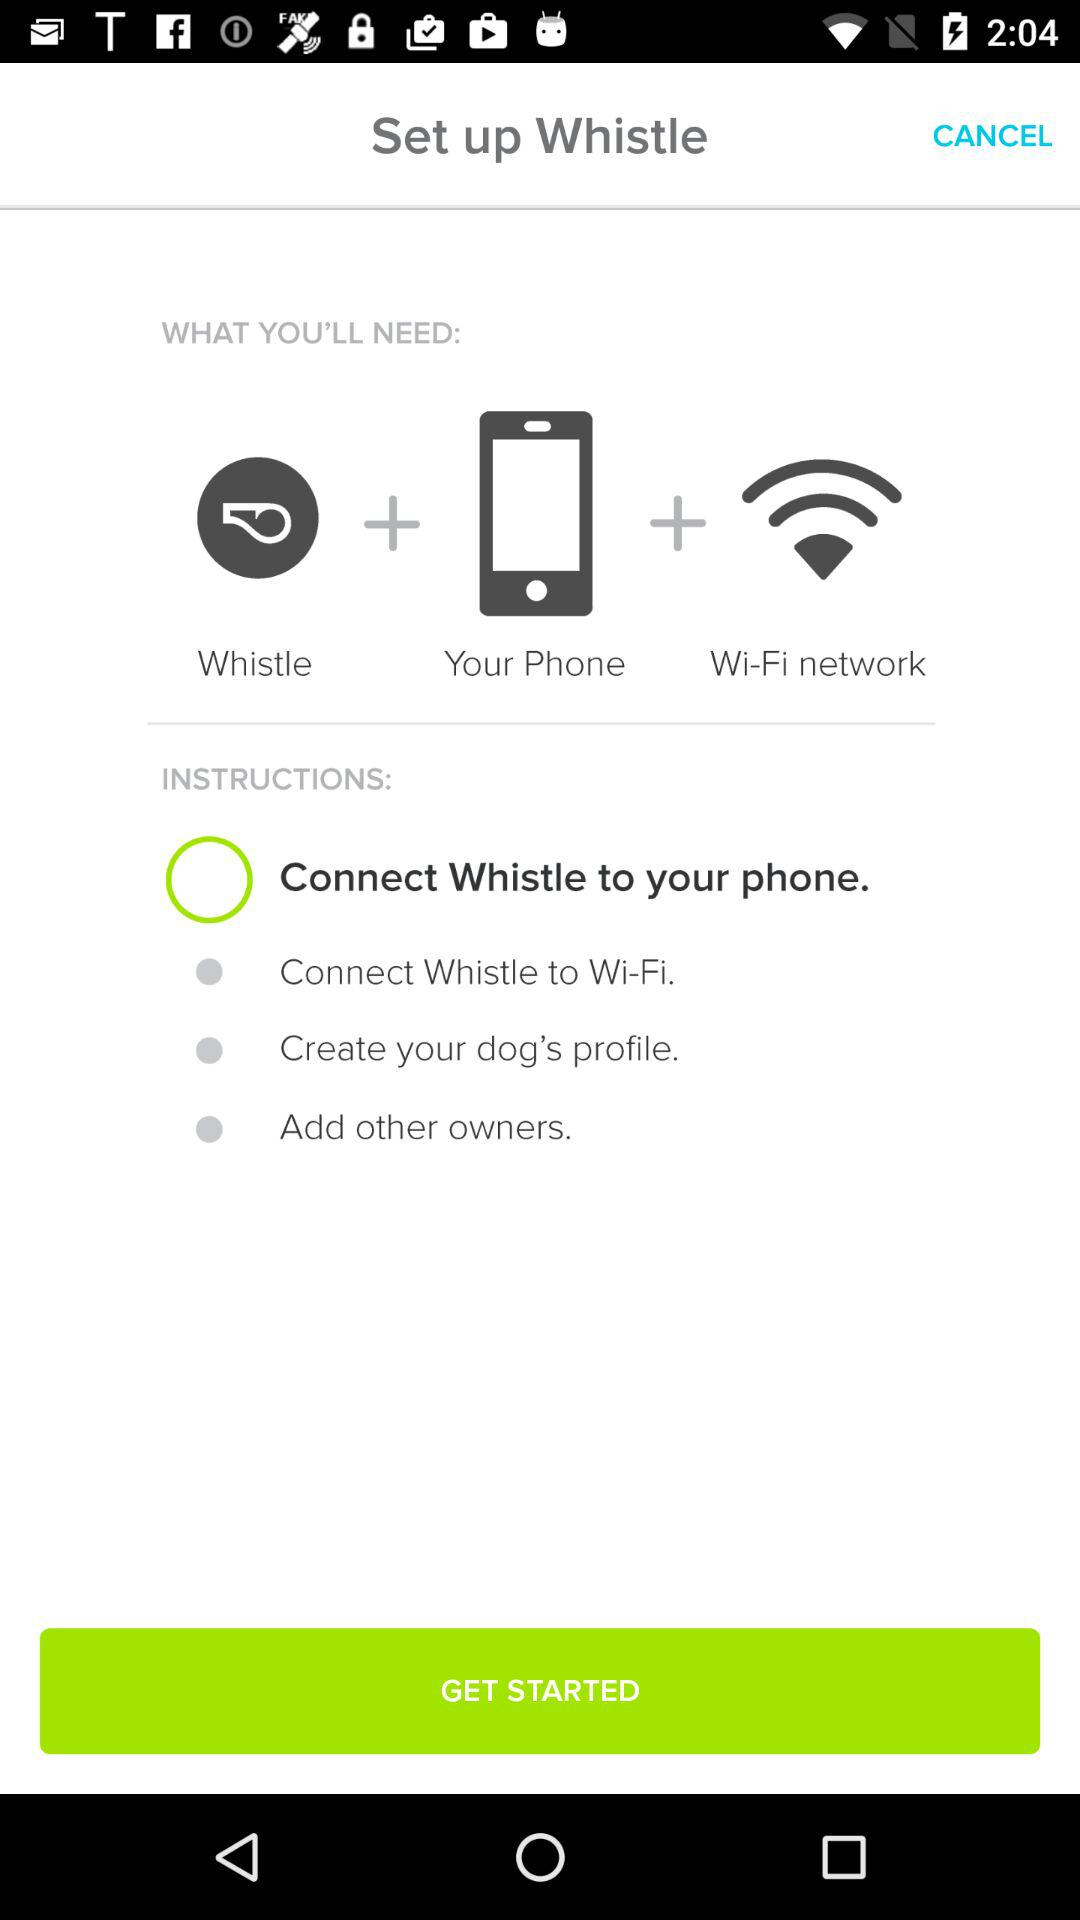What devices are needed to set up the whistle? The devices needed are "Whistle", "Your Phone" and "Wi-Fi network". 